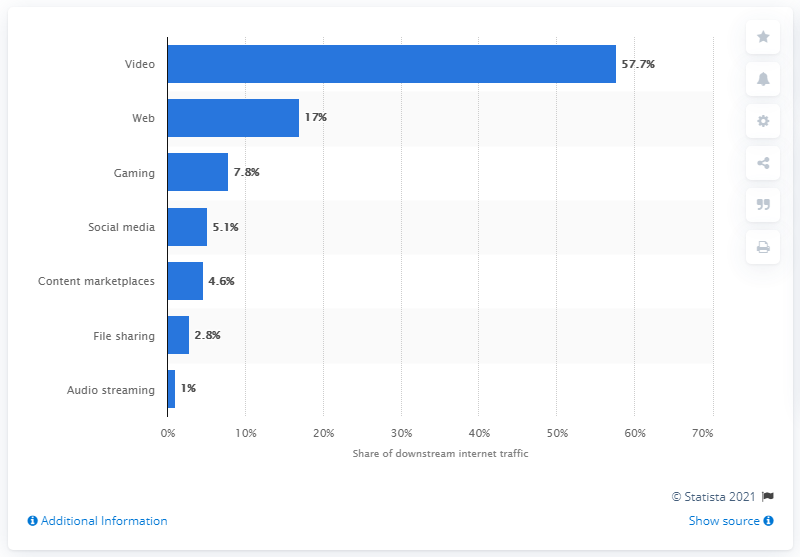Give some essential details in this illustration. The difference between the highest and lowest distribution of global downstream internet traffic is 56.7%. File sharing is the second least distributed form of global downstream internet traffic. 